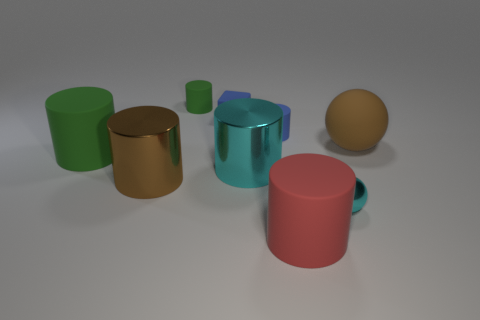Subtract all big red rubber cylinders. How many cylinders are left? 5 Subtract all yellow blocks. How many green cylinders are left? 2 Add 1 cyan objects. How many objects exist? 10 Subtract all cyan cylinders. How many cylinders are left? 5 Subtract 1 balls. How many balls are left? 1 Subtract all cylinders. How many objects are left? 3 Subtract all cyan balls. Subtract all gray blocks. How many balls are left? 1 Subtract all big brown metallic cylinders. Subtract all balls. How many objects are left? 6 Add 8 big brown cylinders. How many big brown cylinders are left? 9 Add 1 big gray cylinders. How many big gray cylinders exist? 1 